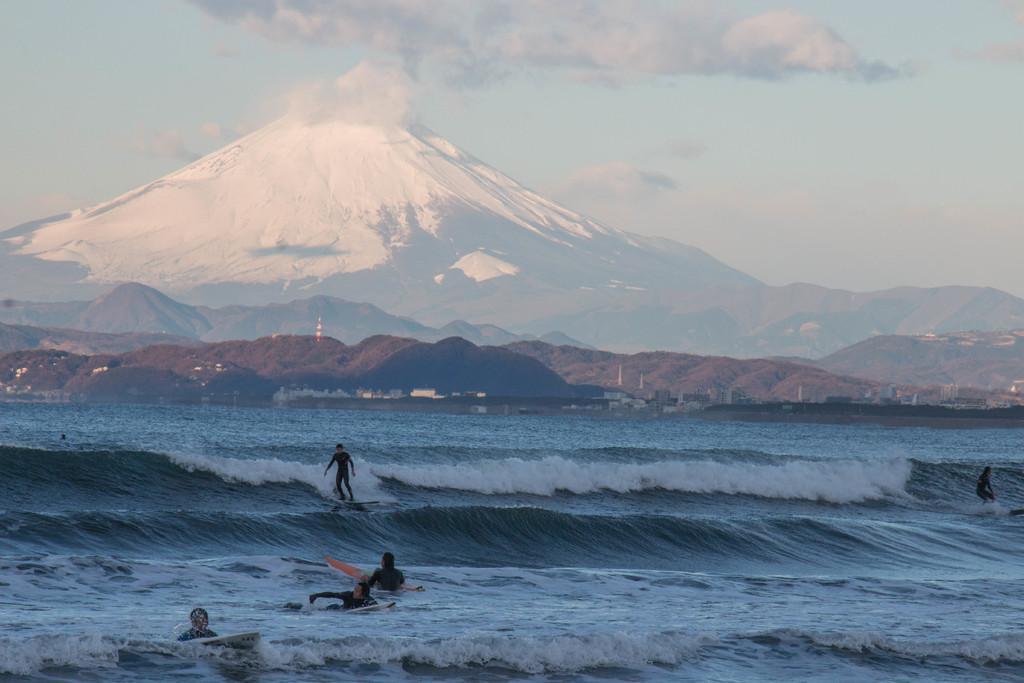Could you give a brief overview of what you see in this image? In this image we can see some group of persons who are surfing on waves and in the background of the image there are some mountains and there is cloudy sky. 